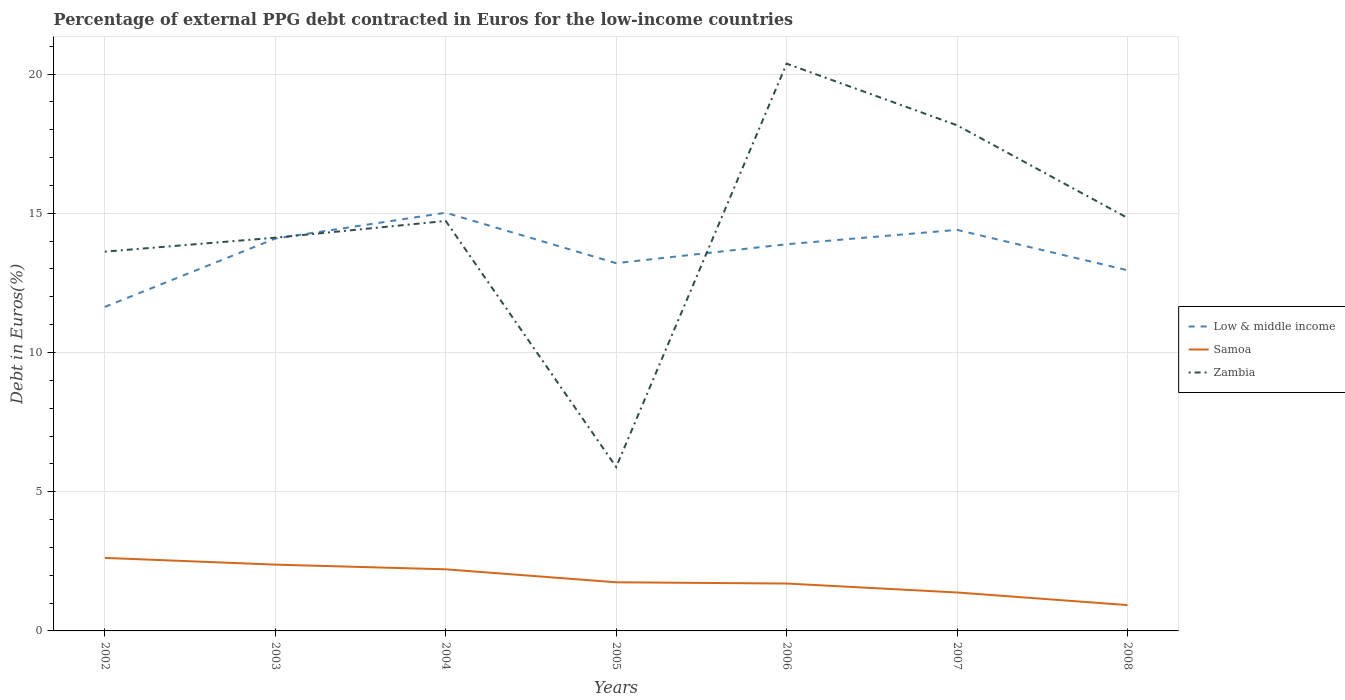How many different coloured lines are there?
Provide a succinct answer. 3. Is the number of lines equal to the number of legend labels?
Your answer should be very brief. Yes. Across all years, what is the maximum percentage of external PPG debt contracted in Euros in Low & middle income?
Offer a very short reply. 11.64. In which year was the percentage of external PPG debt contracted in Euros in Zambia maximum?
Your response must be concise. 2005. What is the total percentage of external PPG debt contracted in Euros in Zambia in the graph?
Your answer should be compact. -6.25. What is the difference between the highest and the second highest percentage of external PPG debt contracted in Euros in Samoa?
Offer a terse response. 1.7. Is the percentage of external PPG debt contracted in Euros in Samoa strictly greater than the percentage of external PPG debt contracted in Euros in Low & middle income over the years?
Your answer should be compact. Yes. How many lines are there?
Ensure brevity in your answer.  3. Does the graph contain any zero values?
Give a very brief answer. No. Does the graph contain grids?
Keep it short and to the point. Yes. Where does the legend appear in the graph?
Make the answer very short. Center right. How are the legend labels stacked?
Your answer should be compact. Vertical. What is the title of the graph?
Your answer should be very brief. Percentage of external PPG debt contracted in Euros for the low-income countries. Does "Slovak Republic" appear as one of the legend labels in the graph?
Provide a short and direct response. No. What is the label or title of the Y-axis?
Give a very brief answer. Debt in Euros(%). What is the Debt in Euros(%) in Low & middle income in 2002?
Make the answer very short. 11.64. What is the Debt in Euros(%) of Samoa in 2002?
Offer a terse response. 2.62. What is the Debt in Euros(%) of Zambia in 2002?
Your response must be concise. 13.62. What is the Debt in Euros(%) in Low & middle income in 2003?
Offer a terse response. 14.09. What is the Debt in Euros(%) of Samoa in 2003?
Give a very brief answer. 2.38. What is the Debt in Euros(%) in Zambia in 2003?
Provide a succinct answer. 14.12. What is the Debt in Euros(%) in Low & middle income in 2004?
Make the answer very short. 15.02. What is the Debt in Euros(%) of Samoa in 2004?
Give a very brief answer. 2.21. What is the Debt in Euros(%) of Zambia in 2004?
Your answer should be compact. 14.72. What is the Debt in Euros(%) in Low & middle income in 2005?
Your answer should be compact. 13.21. What is the Debt in Euros(%) in Samoa in 2005?
Offer a terse response. 1.75. What is the Debt in Euros(%) in Zambia in 2005?
Your answer should be very brief. 5.89. What is the Debt in Euros(%) in Low & middle income in 2006?
Provide a succinct answer. 13.89. What is the Debt in Euros(%) in Samoa in 2006?
Your response must be concise. 1.7. What is the Debt in Euros(%) of Zambia in 2006?
Your answer should be very brief. 20.38. What is the Debt in Euros(%) in Low & middle income in 2007?
Offer a very short reply. 14.4. What is the Debt in Euros(%) of Samoa in 2007?
Ensure brevity in your answer.  1.38. What is the Debt in Euros(%) of Zambia in 2007?
Make the answer very short. 18.16. What is the Debt in Euros(%) of Low & middle income in 2008?
Offer a very short reply. 12.95. What is the Debt in Euros(%) in Samoa in 2008?
Ensure brevity in your answer.  0.93. What is the Debt in Euros(%) in Zambia in 2008?
Provide a succinct answer. 14.83. Across all years, what is the maximum Debt in Euros(%) in Low & middle income?
Ensure brevity in your answer.  15.02. Across all years, what is the maximum Debt in Euros(%) in Samoa?
Offer a terse response. 2.62. Across all years, what is the maximum Debt in Euros(%) in Zambia?
Your response must be concise. 20.38. Across all years, what is the minimum Debt in Euros(%) in Low & middle income?
Your answer should be very brief. 11.64. Across all years, what is the minimum Debt in Euros(%) in Samoa?
Your response must be concise. 0.93. Across all years, what is the minimum Debt in Euros(%) in Zambia?
Provide a succinct answer. 5.89. What is the total Debt in Euros(%) of Low & middle income in the graph?
Provide a short and direct response. 95.21. What is the total Debt in Euros(%) of Samoa in the graph?
Keep it short and to the point. 12.98. What is the total Debt in Euros(%) of Zambia in the graph?
Make the answer very short. 101.73. What is the difference between the Debt in Euros(%) in Low & middle income in 2002 and that in 2003?
Keep it short and to the point. -2.45. What is the difference between the Debt in Euros(%) of Samoa in 2002 and that in 2003?
Give a very brief answer. 0.24. What is the difference between the Debt in Euros(%) in Zambia in 2002 and that in 2003?
Ensure brevity in your answer.  -0.5. What is the difference between the Debt in Euros(%) in Low & middle income in 2002 and that in 2004?
Offer a very short reply. -3.38. What is the difference between the Debt in Euros(%) in Samoa in 2002 and that in 2004?
Offer a very short reply. 0.41. What is the difference between the Debt in Euros(%) of Zambia in 2002 and that in 2004?
Your answer should be very brief. -1.1. What is the difference between the Debt in Euros(%) in Low & middle income in 2002 and that in 2005?
Give a very brief answer. -1.57. What is the difference between the Debt in Euros(%) in Samoa in 2002 and that in 2005?
Ensure brevity in your answer.  0.88. What is the difference between the Debt in Euros(%) in Zambia in 2002 and that in 2005?
Provide a succinct answer. 7.73. What is the difference between the Debt in Euros(%) in Low & middle income in 2002 and that in 2006?
Keep it short and to the point. -2.25. What is the difference between the Debt in Euros(%) in Samoa in 2002 and that in 2006?
Provide a short and direct response. 0.92. What is the difference between the Debt in Euros(%) in Zambia in 2002 and that in 2006?
Your response must be concise. -6.75. What is the difference between the Debt in Euros(%) of Low & middle income in 2002 and that in 2007?
Make the answer very short. -2.77. What is the difference between the Debt in Euros(%) in Samoa in 2002 and that in 2007?
Offer a very short reply. 1.24. What is the difference between the Debt in Euros(%) of Zambia in 2002 and that in 2007?
Your answer should be very brief. -4.54. What is the difference between the Debt in Euros(%) in Low & middle income in 2002 and that in 2008?
Keep it short and to the point. -1.32. What is the difference between the Debt in Euros(%) of Samoa in 2002 and that in 2008?
Ensure brevity in your answer.  1.7. What is the difference between the Debt in Euros(%) in Zambia in 2002 and that in 2008?
Offer a very short reply. -1.21. What is the difference between the Debt in Euros(%) of Low & middle income in 2003 and that in 2004?
Your answer should be very brief. -0.93. What is the difference between the Debt in Euros(%) in Samoa in 2003 and that in 2004?
Your answer should be compact. 0.17. What is the difference between the Debt in Euros(%) of Zambia in 2003 and that in 2004?
Keep it short and to the point. -0.6. What is the difference between the Debt in Euros(%) of Low & middle income in 2003 and that in 2005?
Your answer should be compact. 0.88. What is the difference between the Debt in Euros(%) in Samoa in 2003 and that in 2005?
Give a very brief answer. 0.63. What is the difference between the Debt in Euros(%) of Zambia in 2003 and that in 2005?
Give a very brief answer. 8.24. What is the difference between the Debt in Euros(%) of Low & middle income in 2003 and that in 2006?
Provide a short and direct response. 0.2. What is the difference between the Debt in Euros(%) in Samoa in 2003 and that in 2006?
Give a very brief answer. 0.68. What is the difference between the Debt in Euros(%) in Zambia in 2003 and that in 2006?
Give a very brief answer. -6.25. What is the difference between the Debt in Euros(%) in Low & middle income in 2003 and that in 2007?
Provide a short and direct response. -0.31. What is the difference between the Debt in Euros(%) in Zambia in 2003 and that in 2007?
Make the answer very short. -4.04. What is the difference between the Debt in Euros(%) of Low & middle income in 2003 and that in 2008?
Offer a terse response. 1.14. What is the difference between the Debt in Euros(%) of Samoa in 2003 and that in 2008?
Provide a short and direct response. 1.45. What is the difference between the Debt in Euros(%) of Zambia in 2003 and that in 2008?
Keep it short and to the point. -0.71. What is the difference between the Debt in Euros(%) of Low & middle income in 2004 and that in 2005?
Give a very brief answer. 1.81. What is the difference between the Debt in Euros(%) of Samoa in 2004 and that in 2005?
Provide a succinct answer. 0.47. What is the difference between the Debt in Euros(%) of Zambia in 2004 and that in 2005?
Your answer should be compact. 8.84. What is the difference between the Debt in Euros(%) of Low & middle income in 2004 and that in 2006?
Offer a very short reply. 1.13. What is the difference between the Debt in Euros(%) in Samoa in 2004 and that in 2006?
Give a very brief answer. 0.51. What is the difference between the Debt in Euros(%) of Zambia in 2004 and that in 2006?
Provide a succinct answer. -5.65. What is the difference between the Debt in Euros(%) of Low & middle income in 2004 and that in 2007?
Your answer should be compact. 0.62. What is the difference between the Debt in Euros(%) of Samoa in 2004 and that in 2007?
Provide a succinct answer. 0.83. What is the difference between the Debt in Euros(%) in Zambia in 2004 and that in 2007?
Your answer should be very brief. -3.44. What is the difference between the Debt in Euros(%) in Low & middle income in 2004 and that in 2008?
Your answer should be very brief. 2.07. What is the difference between the Debt in Euros(%) in Samoa in 2004 and that in 2008?
Provide a short and direct response. 1.28. What is the difference between the Debt in Euros(%) of Zambia in 2004 and that in 2008?
Provide a succinct answer. -0.11. What is the difference between the Debt in Euros(%) of Low & middle income in 2005 and that in 2006?
Offer a terse response. -0.68. What is the difference between the Debt in Euros(%) of Samoa in 2005 and that in 2006?
Your answer should be compact. 0.04. What is the difference between the Debt in Euros(%) of Zambia in 2005 and that in 2006?
Provide a short and direct response. -14.49. What is the difference between the Debt in Euros(%) in Low & middle income in 2005 and that in 2007?
Offer a terse response. -1.2. What is the difference between the Debt in Euros(%) in Samoa in 2005 and that in 2007?
Make the answer very short. 0.37. What is the difference between the Debt in Euros(%) of Zambia in 2005 and that in 2007?
Ensure brevity in your answer.  -12.27. What is the difference between the Debt in Euros(%) in Low & middle income in 2005 and that in 2008?
Provide a succinct answer. 0.25. What is the difference between the Debt in Euros(%) in Samoa in 2005 and that in 2008?
Provide a succinct answer. 0.82. What is the difference between the Debt in Euros(%) of Zambia in 2005 and that in 2008?
Provide a short and direct response. -8.95. What is the difference between the Debt in Euros(%) of Low & middle income in 2006 and that in 2007?
Provide a short and direct response. -0.52. What is the difference between the Debt in Euros(%) in Samoa in 2006 and that in 2007?
Your response must be concise. 0.32. What is the difference between the Debt in Euros(%) in Zambia in 2006 and that in 2007?
Your response must be concise. 2.21. What is the difference between the Debt in Euros(%) in Low & middle income in 2006 and that in 2008?
Provide a short and direct response. 0.93. What is the difference between the Debt in Euros(%) of Samoa in 2006 and that in 2008?
Ensure brevity in your answer.  0.77. What is the difference between the Debt in Euros(%) of Zambia in 2006 and that in 2008?
Keep it short and to the point. 5.54. What is the difference between the Debt in Euros(%) in Low & middle income in 2007 and that in 2008?
Offer a very short reply. 1.45. What is the difference between the Debt in Euros(%) of Samoa in 2007 and that in 2008?
Keep it short and to the point. 0.45. What is the difference between the Debt in Euros(%) of Zambia in 2007 and that in 2008?
Keep it short and to the point. 3.33. What is the difference between the Debt in Euros(%) of Low & middle income in 2002 and the Debt in Euros(%) of Samoa in 2003?
Provide a succinct answer. 9.26. What is the difference between the Debt in Euros(%) of Low & middle income in 2002 and the Debt in Euros(%) of Zambia in 2003?
Provide a short and direct response. -2.49. What is the difference between the Debt in Euros(%) of Samoa in 2002 and the Debt in Euros(%) of Zambia in 2003?
Provide a succinct answer. -11.5. What is the difference between the Debt in Euros(%) of Low & middle income in 2002 and the Debt in Euros(%) of Samoa in 2004?
Your response must be concise. 9.43. What is the difference between the Debt in Euros(%) of Low & middle income in 2002 and the Debt in Euros(%) of Zambia in 2004?
Your answer should be compact. -3.09. What is the difference between the Debt in Euros(%) of Samoa in 2002 and the Debt in Euros(%) of Zambia in 2004?
Provide a succinct answer. -12.1. What is the difference between the Debt in Euros(%) of Low & middle income in 2002 and the Debt in Euros(%) of Samoa in 2005?
Offer a terse response. 9.89. What is the difference between the Debt in Euros(%) in Low & middle income in 2002 and the Debt in Euros(%) in Zambia in 2005?
Your answer should be compact. 5.75. What is the difference between the Debt in Euros(%) of Samoa in 2002 and the Debt in Euros(%) of Zambia in 2005?
Your answer should be very brief. -3.26. What is the difference between the Debt in Euros(%) of Low & middle income in 2002 and the Debt in Euros(%) of Samoa in 2006?
Provide a succinct answer. 9.94. What is the difference between the Debt in Euros(%) of Low & middle income in 2002 and the Debt in Euros(%) of Zambia in 2006?
Your answer should be compact. -8.74. What is the difference between the Debt in Euros(%) of Samoa in 2002 and the Debt in Euros(%) of Zambia in 2006?
Your response must be concise. -17.75. What is the difference between the Debt in Euros(%) in Low & middle income in 2002 and the Debt in Euros(%) in Samoa in 2007?
Provide a short and direct response. 10.26. What is the difference between the Debt in Euros(%) of Low & middle income in 2002 and the Debt in Euros(%) of Zambia in 2007?
Your answer should be compact. -6.52. What is the difference between the Debt in Euros(%) of Samoa in 2002 and the Debt in Euros(%) of Zambia in 2007?
Your answer should be very brief. -15.54. What is the difference between the Debt in Euros(%) of Low & middle income in 2002 and the Debt in Euros(%) of Samoa in 2008?
Make the answer very short. 10.71. What is the difference between the Debt in Euros(%) in Low & middle income in 2002 and the Debt in Euros(%) in Zambia in 2008?
Give a very brief answer. -3.2. What is the difference between the Debt in Euros(%) in Samoa in 2002 and the Debt in Euros(%) in Zambia in 2008?
Your answer should be compact. -12.21. What is the difference between the Debt in Euros(%) of Low & middle income in 2003 and the Debt in Euros(%) of Samoa in 2004?
Your answer should be very brief. 11.88. What is the difference between the Debt in Euros(%) in Low & middle income in 2003 and the Debt in Euros(%) in Zambia in 2004?
Offer a terse response. -0.63. What is the difference between the Debt in Euros(%) of Samoa in 2003 and the Debt in Euros(%) of Zambia in 2004?
Keep it short and to the point. -12.34. What is the difference between the Debt in Euros(%) of Low & middle income in 2003 and the Debt in Euros(%) of Samoa in 2005?
Your answer should be compact. 12.35. What is the difference between the Debt in Euros(%) of Low & middle income in 2003 and the Debt in Euros(%) of Zambia in 2005?
Your answer should be very brief. 8.21. What is the difference between the Debt in Euros(%) of Samoa in 2003 and the Debt in Euros(%) of Zambia in 2005?
Your answer should be very brief. -3.51. What is the difference between the Debt in Euros(%) in Low & middle income in 2003 and the Debt in Euros(%) in Samoa in 2006?
Offer a very short reply. 12.39. What is the difference between the Debt in Euros(%) in Low & middle income in 2003 and the Debt in Euros(%) in Zambia in 2006?
Your answer should be compact. -6.28. What is the difference between the Debt in Euros(%) of Samoa in 2003 and the Debt in Euros(%) of Zambia in 2006?
Offer a very short reply. -17.99. What is the difference between the Debt in Euros(%) of Low & middle income in 2003 and the Debt in Euros(%) of Samoa in 2007?
Offer a very short reply. 12.71. What is the difference between the Debt in Euros(%) in Low & middle income in 2003 and the Debt in Euros(%) in Zambia in 2007?
Provide a short and direct response. -4.07. What is the difference between the Debt in Euros(%) in Samoa in 2003 and the Debt in Euros(%) in Zambia in 2007?
Ensure brevity in your answer.  -15.78. What is the difference between the Debt in Euros(%) in Low & middle income in 2003 and the Debt in Euros(%) in Samoa in 2008?
Provide a short and direct response. 13.16. What is the difference between the Debt in Euros(%) in Low & middle income in 2003 and the Debt in Euros(%) in Zambia in 2008?
Provide a short and direct response. -0.74. What is the difference between the Debt in Euros(%) of Samoa in 2003 and the Debt in Euros(%) of Zambia in 2008?
Give a very brief answer. -12.45. What is the difference between the Debt in Euros(%) in Low & middle income in 2004 and the Debt in Euros(%) in Samoa in 2005?
Provide a succinct answer. 13.27. What is the difference between the Debt in Euros(%) in Low & middle income in 2004 and the Debt in Euros(%) in Zambia in 2005?
Offer a very short reply. 9.13. What is the difference between the Debt in Euros(%) of Samoa in 2004 and the Debt in Euros(%) of Zambia in 2005?
Provide a succinct answer. -3.68. What is the difference between the Debt in Euros(%) of Low & middle income in 2004 and the Debt in Euros(%) of Samoa in 2006?
Provide a succinct answer. 13.32. What is the difference between the Debt in Euros(%) of Low & middle income in 2004 and the Debt in Euros(%) of Zambia in 2006?
Your response must be concise. -5.35. What is the difference between the Debt in Euros(%) of Samoa in 2004 and the Debt in Euros(%) of Zambia in 2006?
Make the answer very short. -18.16. What is the difference between the Debt in Euros(%) of Low & middle income in 2004 and the Debt in Euros(%) of Samoa in 2007?
Give a very brief answer. 13.64. What is the difference between the Debt in Euros(%) of Low & middle income in 2004 and the Debt in Euros(%) of Zambia in 2007?
Offer a terse response. -3.14. What is the difference between the Debt in Euros(%) of Samoa in 2004 and the Debt in Euros(%) of Zambia in 2007?
Offer a terse response. -15.95. What is the difference between the Debt in Euros(%) in Low & middle income in 2004 and the Debt in Euros(%) in Samoa in 2008?
Make the answer very short. 14.09. What is the difference between the Debt in Euros(%) in Low & middle income in 2004 and the Debt in Euros(%) in Zambia in 2008?
Offer a terse response. 0.19. What is the difference between the Debt in Euros(%) in Samoa in 2004 and the Debt in Euros(%) in Zambia in 2008?
Provide a succinct answer. -12.62. What is the difference between the Debt in Euros(%) in Low & middle income in 2005 and the Debt in Euros(%) in Samoa in 2006?
Provide a short and direct response. 11.51. What is the difference between the Debt in Euros(%) in Low & middle income in 2005 and the Debt in Euros(%) in Zambia in 2006?
Your answer should be compact. -7.17. What is the difference between the Debt in Euros(%) of Samoa in 2005 and the Debt in Euros(%) of Zambia in 2006?
Offer a very short reply. -18.63. What is the difference between the Debt in Euros(%) of Low & middle income in 2005 and the Debt in Euros(%) of Samoa in 2007?
Make the answer very short. 11.83. What is the difference between the Debt in Euros(%) of Low & middle income in 2005 and the Debt in Euros(%) of Zambia in 2007?
Make the answer very short. -4.95. What is the difference between the Debt in Euros(%) in Samoa in 2005 and the Debt in Euros(%) in Zambia in 2007?
Give a very brief answer. -16.41. What is the difference between the Debt in Euros(%) in Low & middle income in 2005 and the Debt in Euros(%) in Samoa in 2008?
Give a very brief answer. 12.28. What is the difference between the Debt in Euros(%) of Low & middle income in 2005 and the Debt in Euros(%) of Zambia in 2008?
Your response must be concise. -1.63. What is the difference between the Debt in Euros(%) in Samoa in 2005 and the Debt in Euros(%) in Zambia in 2008?
Provide a short and direct response. -13.09. What is the difference between the Debt in Euros(%) of Low & middle income in 2006 and the Debt in Euros(%) of Samoa in 2007?
Provide a short and direct response. 12.51. What is the difference between the Debt in Euros(%) in Low & middle income in 2006 and the Debt in Euros(%) in Zambia in 2007?
Offer a terse response. -4.27. What is the difference between the Debt in Euros(%) in Samoa in 2006 and the Debt in Euros(%) in Zambia in 2007?
Your answer should be very brief. -16.46. What is the difference between the Debt in Euros(%) in Low & middle income in 2006 and the Debt in Euros(%) in Samoa in 2008?
Your response must be concise. 12.96. What is the difference between the Debt in Euros(%) of Low & middle income in 2006 and the Debt in Euros(%) of Zambia in 2008?
Provide a short and direct response. -0.95. What is the difference between the Debt in Euros(%) of Samoa in 2006 and the Debt in Euros(%) of Zambia in 2008?
Make the answer very short. -13.13. What is the difference between the Debt in Euros(%) of Low & middle income in 2007 and the Debt in Euros(%) of Samoa in 2008?
Provide a succinct answer. 13.48. What is the difference between the Debt in Euros(%) in Low & middle income in 2007 and the Debt in Euros(%) in Zambia in 2008?
Keep it short and to the point. -0.43. What is the difference between the Debt in Euros(%) of Samoa in 2007 and the Debt in Euros(%) of Zambia in 2008?
Provide a succinct answer. -13.45. What is the average Debt in Euros(%) in Low & middle income per year?
Make the answer very short. 13.6. What is the average Debt in Euros(%) in Samoa per year?
Provide a short and direct response. 1.85. What is the average Debt in Euros(%) in Zambia per year?
Give a very brief answer. 14.53. In the year 2002, what is the difference between the Debt in Euros(%) of Low & middle income and Debt in Euros(%) of Samoa?
Provide a short and direct response. 9.02. In the year 2002, what is the difference between the Debt in Euros(%) in Low & middle income and Debt in Euros(%) in Zambia?
Provide a succinct answer. -1.98. In the year 2002, what is the difference between the Debt in Euros(%) of Samoa and Debt in Euros(%) of Zambia?
Your answer should be compact. -11. In the year 2003, what is the difference between the Debt in Euros(%) in Low & middle income and Debt in Euros(%) in Samoa?
Provide a succinct answer. 11.71. In the year 2003, what is the difference between the Debt in Euros(%) of Low & middle income and Debt in Euros(%) of Zambia?
Offer a terse response. -0.03. In the year 2003, what is the difference between the Debt in Euros(%) of Samoa and Debt in Euros(%) of Zambia?
Your answer should be very brief. -11.74. In the year 2004, what is the difference between the Debt in Euros(%) of Low & middle income and Debt in Euros(%) of Samoa?
Keep it short and to the point. 12.81. In the year 2004, what is the difference between the Debt in Euros(%) of Low & middle income and Debt in Euros(%) of Zambia?
Make the answer very short. 0.3. In the year 2004, what is the difference between the Debt in Euros(%) in Samoa and Debt in Euros(%) in Zambia?
Keep it short and to the point. -12.51. In the year 2005, what is the difference between the Debt in Euros(%) in Low & middle income and Debt in Euros(%) in Samoa?
Your answer should be compact. 11.46. In the year 2005, what is the difference between the Debt in Euros(%) of Low & middle income and Debt in Euros(%) of Zambia?
Provide a succinct answer. 7.32. In the year 2005, what is the difference between the Debt in Euros(%) in Samoa and Debt in Euros(%) in Zambia?
Ensure brevity in your answer.  -4.14. In the year 2006, what is the difference between the Debt in Euros(%) in Low & middle income and Debt in Euros(%) in Samoa?
Provide a succinct answer. 12.19. In the year 2006, what is the difference between the Debt in Euros(%) in Low & middle income and Debt in Euros(%) in Zambia?
Give a very brief answer. -6.49. In the year 2006, what is the difference between the Debt in Euros(%) of Samoa and Debt in Euros(%) of Zambia?
Offer a terse response. -18.67. In the year 2007, what is the difference between the Debt in Euros(%) of Low & middle income and Debt in Euros(%) of Samoa?
Offer a terse response. 13.02. In the year 2007, what is the difference between the Debt in Euros(%) in Low & middle income and Debt in Euros(%) in Zambia?
Your answer should be very brief. -3.76. In the year 2007, what is the difference between the Debt in Euros(%) in Samoa and Debt in Euros(%) in Zambia?
Provide a succinct answer. -16.78. In the year 2008, what is the difference between the Debt in Euros(%) in Low & middle income and Debt in Euros(%) in Samoa?
Keep it short and to the point. 12.03. In the year 2008, what is the difference between the Debt in Euros(%) of Low & middle income and Debt in Euros(%) of Zambia?
Keep it short and to the point. -1.88. In the year 2008, what is the difference between the Debt in Euros(%) in Samoa and Debt in Euros(%) in Zambia?
Provide a succinct answer. -13.91. What is the ratio of the Debt in Euros(%) of Low & middle income in 2002 to that in 2003?
Offer a very short reply. 0.83. What is the ratio of the Debt in Euros(%) in Samoa in 2002 to that in 2003?
Give a very brief answer. 1.1. What is the ratio of the Debt in Euros(%) in Zambia in 2002 to that in 2003?
Offer a terse response. 0.96. What is the ratio of the Debt in Euros(%) of Low & middle income in 2002 to that in 2004?
Offer a terse response. 0.77. What is the ratio of the Debt in Euros(%) of Samoa in 2002 to that in 2004?
Your answer should be very brief. 1.19. What is the ratio of the Debt in Euros(%) in Zambia in 2002 to that in 2004?
Your answer should be very brief. 0.93. What is the ratio of the Debt in Euros(%) in Low & middle income in 2002 to that in 2005?
Provide a succinct answer. 0.88. What is the ratio of the Debt in Euros(%) in Samoa in 2002 to that in 2005?
Offer a terse response. 1.5. What is the ratio of the Debt in Euros(%) in Zambia in 2002 to that in 2005?
Ensure brevity in your answer.  2.31. What is the ratio of the Debt in Euros(%) of Low & middle income in 2002 to that in 2006?
Ensure brevity in your answer.  0.84. What is the ratio of the Debt in Euros(%) of Samoa in 2002 to that in 2006?
Keep it short and to the point. 1.54. What is the ratio of the Debt in Euros(%) of Zambia in 2002 to that in 2006?
Make the answer very short. 0.67. What is the ratio of the Debt in Euros(%) of Low & middle income in 2002 to that in 2007?
Give a very brief answer. 0.81. What is the ratio of the Debt in Euros(%) of Samoa in 2002 to that in 2007?
Your response must be concise. 1.9. What is the ratio of the Debt in Euros(%) of Zambia in 2002 to that in 2007?
Your response must be concise. 0.75. What is the ratio of the Debt in Euros(%) of Low & middle income in 2002 to that in 2008?
Your response must be concise. 0.9. What is the ratio of the Debt in Euros(%) in Samoa in 2002 to that in 2008?
Offer a very short reply. 2.83. What is the ratio of the Debt in Euros(%) of Zambia in 2002 to that in 2008?
Your answer should be compact. 0.92. What is the ratio of the Debt in Euros(%) of Low & middle income in 2003 to that in 2004?
Keep it short and to the point. 0.94. What is the ratio of the Debt in Euros(%) in Samoa in 2003 to that in 2004?
Make the answer very short. 1.08. What is the ratio of the Debt in Euros(%) of Zambia in 2003 to that in 2004?
Make the answer very short. 0.96. What is the ratio of the Debt in Euros(%) of Low & middle income in 2003 to that in 2005?
Give a very brief answer. 1.07. What is the ratio of the Debt in Euros(%) of Samoa in 2003 to that in 2005?
Offer a terse response. 1.36. What is the ratio of the Debt in Euros(%) of Zambia in 2003 to that in 2005?
Offer a terse response. 2.4. What is the ratio of the Debt in Euros(%) in Low & middle income in 2003 to that in 2006?
Keep it short and to the point. 1.01. What is the ratio of the Debt in Euros(%) of Samoa in 2003 to that in 2006?
Make the answer very short. 1.4. What is the ratio of the Debt in Euros(%) of Zambia in 2003 to that in 2006?
Your answer should be very brief. 0.69. What is the ratio of the Debt in Euros(%) of Low & middle income in 2003 to that in 2007?
Your answer should be very brief. 0.98. What is the ratio of the Debt in Euros(%) of Samoa in 2003 to that in 2007?
Offer a terse response. 1.72. What is the ratio of the Debt in Euros(%) of Zambia in 2003 to that in 2007?
Your response must be concise. 0.78. What is the ratio of the Debt in Euros(%) of Low & middle income in 2003 to that in 2008?
Provide a short and direct response. 1.09. What is the ratio of the Debt in Euros(%) in Samoa in 2003 to that in 2008?
Offer a terse response. 2.57. What is the ratio of the Debt in Euros(%) in Zambia in 2003 to that in 2008?
Your answer should be compact. 0.95. What is the ratio of the Debt in Euros(%) in Low & middle income in 2004 to that in 2005?
Offer a very short reply. 1.14. What is the ratio of the Debt in Euros(%) in Samoa in 2004 to that in 2005?
Provide a short and direct response. 1.27. What is the ratio of the Debt in Euros(%) in Zambia in 2004 to that in 2005?
Provide a succinct answer. 2.5. What is the ratio of the Debt in Euros(%) in Low & middle income in 2004 to that in 2006?
Your response must be concise. 1.08. What is the ratio of the Debt in Euros(%) in Samoa in 2004 to that in 2006?
Provide a short and direct response. 1.3. What is the ratio of the Debt in Euros(%) of Zambia in 2004 to that in 2006?
Keep it short and to the point. 0.72. What is the ratio of the Debt in Euros(%) in Low & middle income in 2004 to that in 2007?
Keep it short and to the point. 1.04. What is the ratio of the Debt in Euros(%) in Samoa in 2004 to that in 2007?
Offer a very short reply. 1.6. What is the ratio of the Debt in Euros(%) of Zambia in 2004 to that in 2007?
Provide a short and direct response. 0.81. What is the ratio of the Debt in Euros(%) of Low & middle income in 2004 to that in 2008?
Make the answer very short. 1.16. What is the ratio of the Debt in Euros(%) of Samoa in 2004 to that in 2008?
Give a very brief answer. 2.38. What is the ratio of the Debt in Euros(%) in Zambia in 2004 to that in 2008?
Offer a terse response. 0.99. What is the ratio of the Debt in Euros(%) in Low & middle income in 2005 to that in 2006?
Keep it short and to the point. 0.95. What is the ratio of the Debt in Euros(%) of Samoa in 2005 to that in 2006?
Give a very brief answer. 1.03. What is the ratio of the Debt in Euros(%) of Zambia in 2005 to that in 2006?
Your answer should be very brief. 0.29. What is the ratio of the Debt in Euros(%) of Low & middle income in 2005 to that in 2007?
Give a very brief answer. 0.92. What is the ratio of the Debt in Euros(%) in Samoa in 2005 to that in 2007?
Offer a very short reply. 1.27. What is the ratio of the Debt in Euros(%) in Zambia in 2005 to that in 2007?
Make the answer very short. 0.32. What is the ratio of the Debt in Euros(%) in Low & middle income in 2005 to that in 2008?
Keep it short and to the point. 1.02. What is the ratio of the Debt in Euros(%) of Samoa in 2005 to that in 2008?
Give a very brief answer. 1.88. What is the ratio of the Debt in Euros(%) in Zambia in 2005 to that in 2008?
Provide a succinct answer. 0.4. What is the ratio of the Debt in Euros(%) of Low & middle income in 2006 to that in 2007?
Give a very brief answer. 0.96. What is the ratio of the Debt in Euros(%) of Samoa in 2006 to that in 2007?
Keep it short and to the point. 1.23. What is the ratio of the Debt in Euros(%) of Zambia in 2006 to that in 2007?
Your response must be concise. 1.12. What is the ratio of the Debt in Euros(%) of Low & middle income in 2006 to that in 2008?
Your answer should be compact. 1.07. What is the ratio of the Debt in Euros(%) of Samoa in 2006 to that in 2008?
Ensure brevity in your answer.  1.83. What is the ratio of the Debt in Euros(%) in Zambia in 2006 to that in 2008?
Keep it short and to the point. 1.37. What is the ratio of the Debt in Euros(%) in Low & middle income in 2007 to that in 2008?
Provide a short and direct response. 1.11. What is the ratio of the Debt in Euros(%) in Samoa in 2007 to that in 2008?
Provide a succinct answer. 1.49. What is the ratio of the Debt in Euros(%) in Zambia in 2007 to that in 2008?
Keep it short and to the point. 1.22. What is the difference between the highest and the second highest Debt in Euros(%) of Low & middle income?
Keep it short and to the point. 0.62. What is the difference between the highest and the second highest Debt in Euros(%) of Samoa?
Provide a succinct answer. 0.24. What is the difference between the highest and the second highest Debt in Euros(%) of Zambia?
Provide a succinct answer. 2.21. What is the difference between the highest and the lowest Debt in Euros(%) in Low & middle income?
Your answer should be very brief. 3.38. What is the difference between the highest and the lowest Debt in Euros(%) of Samoa?
Give a very brief answer. 1.7. What is the difference between the highest and the lowest Debt in Euros(%) of Zambia?
Provide a succinct answer. 14.49. 